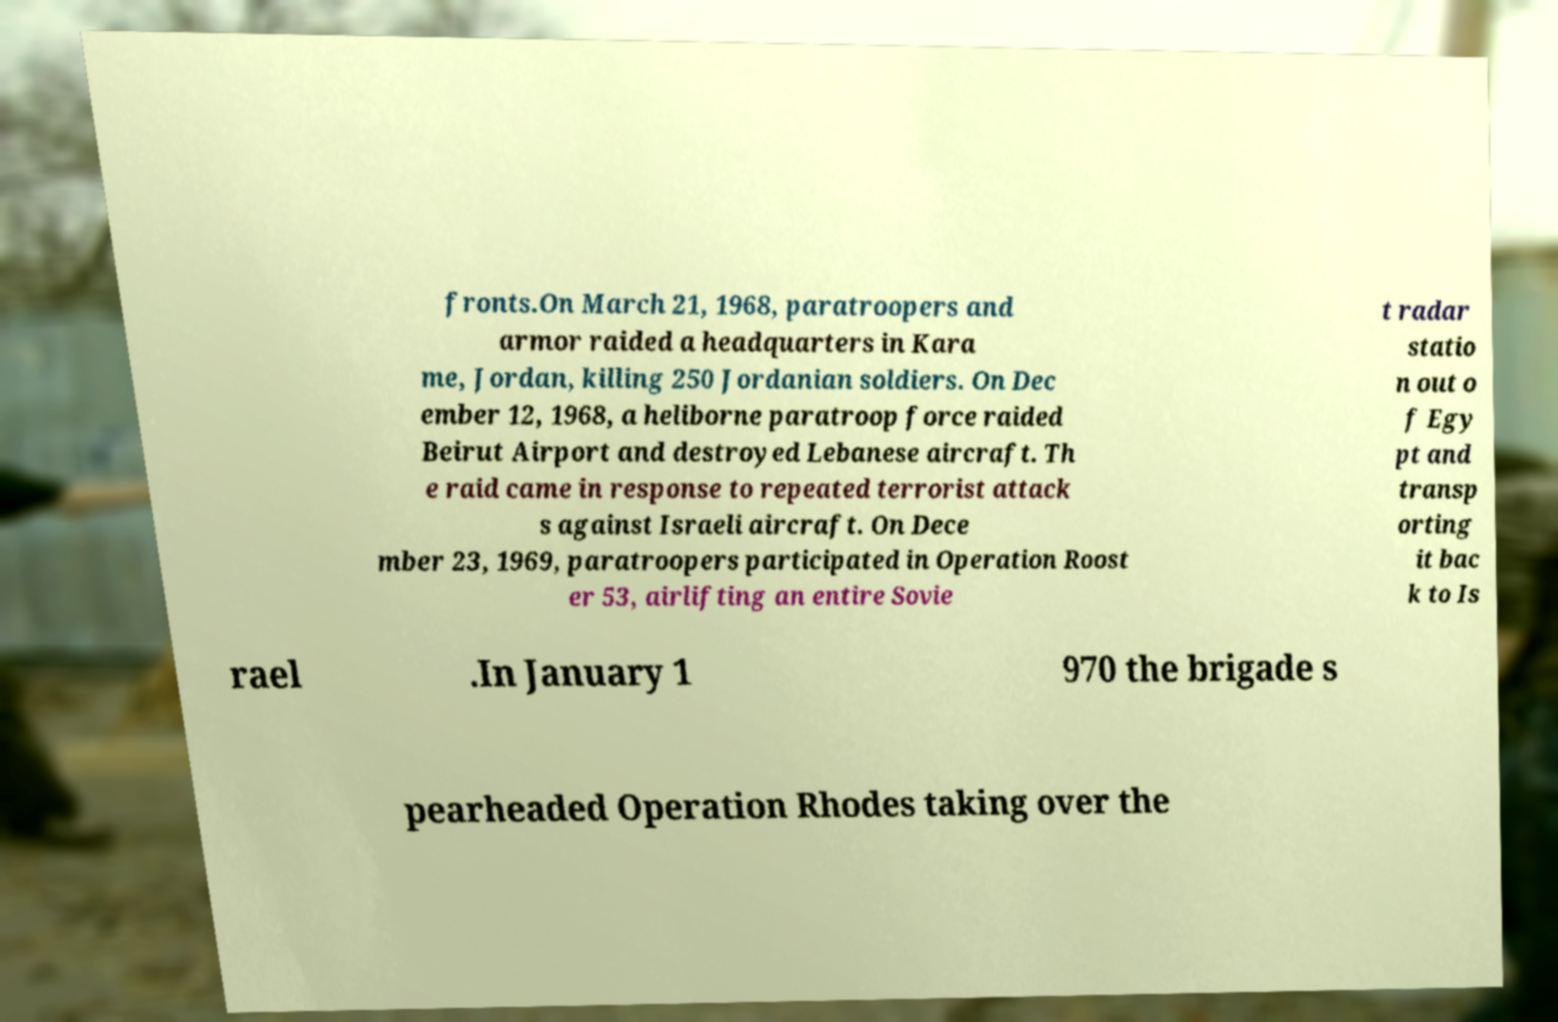I need the written content from this picture converted into text. Can you do that? fronts.On March 21, 1968, paratroopers and armor raided a headquarters in Kara me, Jordan, killing 250 Jordanian soldiers. On Dec ember 12, 1968, a heliborne paratroop force raided Beirut Airport and destroyed Lebanese aircraft. Th e raid came in response to repeated terrorist attack s against Israeli aircraft. On Dece mber 23, 1969, paratroopers participated in Operation Roost er 53, airlifting an entire Sovie t radar statio n out o f Egy pt and transp orting it bac k to Is rael .In January 1 970 the brigade s pearheaded Operation Rhodes taking over the 